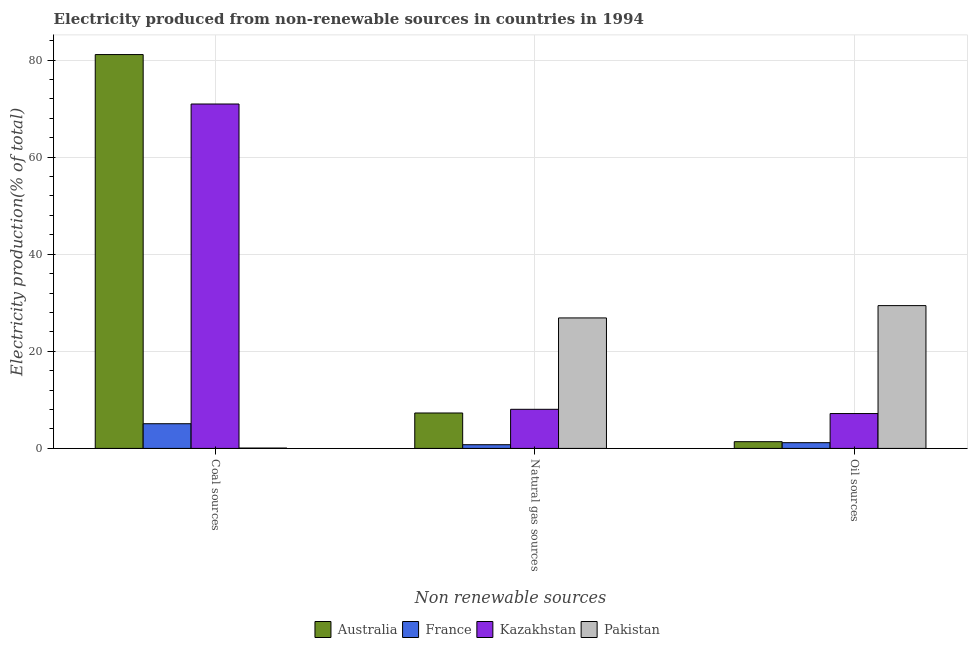How many different coloured bars are there?
Offer a very short reply. 4. How many groups of bars are there?
Your answer should be compact. 3. Are the number of bars on each tick of the X-axis equal?
Provide a short and direct response. Yes. What is the label of the 2nd group of bars from the left?
Your response must be concise. Natural gas sources. What is the percentage of electricity produced by natural gas in Australia?
Make the answer very short. 7.3. Across all countries, what is the maximum percentage of electricity produced by oil sources?
Ensure brevity in your answer.  29.41. Across all countries, what is the minimum percentage of electricity produced by natural gas?
Make the answer very short. 0.76. In which country was the percentage of electricity produced by oil sources maximum?
Provide a short and direct response. Pakistan. What is the total percentage of electricity produced by coal in the graph?
Offer a very short reply. 157.22. What is the difference between the percentage of electricity produced by natural gas in France and that in Australia?
Provide a short and direct response. -6.53. What is the difference between the percentage of electricity produced by natural gas in France and the percentage of electricity produced by coal in Pakistan?
Ensure brevity in your answer.  0.69. What is the average percentage of electricity produced by coal per country?
Provide a short and direct response. 39.3. What is the difference between the percentage of electricity produced by natural gas and percentage of electricity produced by coal in Kazakhstan?
Offer a terse response. -62.88. In how many countries, is the percentage of electricity produced by oil sources greater than 36 %?
Your answer should be compact. 0. What is the ratio of the percentage of electricity produced by coal in France to that in Australia?
Your answer should be compact. 0.06. Is the percentage of electricity produced by coal in France less than that in Kazakhstan?
Offer a very short reply. Yes. What is the difference between the highest and the second highest percentage of electricity produced by coal?
Offer a terse response. 10.18. What is the difference between the highest and the lowest percentage of electricity produced by oil sources?
Provide a succinct answer. 28.23. Is the sum of the percentage of electricity produced by oil sources in Kazakhstan and Pakistan greater than the maximum percentage of electricity produced by natural gas across all countries?
Provide a short and direct response. Yes. What does the 4th bar from the left in Natural gas sources represents?
Offer a very short reply. Pakistan. Is it the case that in every country, the sum of the percentage of electricity produced by coal and percentage of electricity produced by natural gas is greater than the percentage of electricity produced by oil sources?
Your answer should be compact. No. Are all the bars in the graph horizontal?
Provide a succinct answer. No. How many countries are there in the graph?
Offer a terse response. 4. Are the values on the major ticks of Y-axis written in scientific E-notation?
Provide a short and direct response. No. Does the graph contain any zero values?
Make the answer very short. No. Does the graph contain grids?
Offer a terse response. Yes. How many legend labels are there?
Offer a very short reply. 4. What is the title of the graph?
Offer a terse response. Electricity produced from non-renewable sources in countries in 1994. Does "Somalia" appear as one of the legend labels in the graph?
Give a very brief answer. No. What is the label or title of the X-axis?
Your answer should be very brief. Non renewable sources. What is the label or title of the Y-axis?
Make the answer very short. Electricity production(% of total). What is the Electricity production(% of total) in Australia in Coal sources?
Offer a terse response. 81.12. What is the Electricity production(% of total) in France in Coal sources?
Ensure brevity in your answer.  5.09. What is the Electricity production(% of total) in Kazakhstan in Coal sources?
Provide a short and direct response. 70.94. What is the Electricity production(% of total) of Pakistan in Coal sources?
Your answer should be very brief. 0.07. What is the Electricity production(% of total) of Australia in Natural gas sources?
Offer a terse response. 7.3. What is the Electricity production(% of total) of France in Natural gas sources?
Your answer should be very brief. 0.76. What is the Electricity production(% of total) in Kazakhstan in Natural gas sources?
Your answer should be compact. 8.06. What is the Electricity production(% of total) of Pakistan in Natural gas sources?
Make the answer very short. 26.88. What is the Electricity production(% of total) in Australia in Oil sources?
Make the answer very short. 1.39. What is the Electricity production(% of total) in France in Oil sources?
Make the answer very short. 1.18. What is the Electricity production(% of total) of Kazakhstan in Oil sources?
Ensure brevity in your answer.  7.18. What is the Electricity production(% of total) of Pakistan in Oil sources?
Provide a succinct answer. 29.41. Across all Non renewable sources, what is the maximum Electricity production(% of total) of Australia?
Ensure brevity in your answer.  81.12. Across all Non renewable sources, what is the maximum Electricity production(% of total) in France?
Your answer should be compact. 5.09. Across all Non renewable sources, what is the maximum Electricity production(% of total) in Kazakhstan?
Keep it short and to the point. 70.94. Across all Non renewable sources, what is the maximum Electricity production(% of total) in Pakistan?
Offer a very short reply. 29.41. Across all Non renewable sources, what is the minimum Electricity production(% of total) of Australia?
Provide a succinct answer. 1.39. Across all Non renewable sources, what is the minimum Electricity production(% of total) in France?
Your answer should be compact. 0.76. Across all Non renewable sources, what is the minimum Electricity production(% of total) of Kazakhstan?
Provide a succinct answer. 7.18. Across all Non renewable sources, what is the minimum Electricity production(% of total) of Pakistan?
Your answer should be very brief. 0.07. What is the total Electricity production(% of total) of Australia in the graph?
Your answer should be very brief. 89.81. What is the total Electricity production(% of total) of France in the graph?
Provide a succinct answer. 7.03. What is the total Electricity production(% of total) of Kazakhstan in the graph?
Offer a very short reply. 86.18. What is the total Electricity production(% of total) in Pakistan in the graph?
Ensure brevity in your answer.  56.36. What is the difference between the Electricity production(% of total) of Australia in Coal sources and that in Natural gas sources?
Offer a terse response. 73.82. What is the difference between the Electricity production(% of total) in France in Coal sources and that in Natural gas sources?
Make the answer very short. 4.32. What is the difference between the Electricity production(% of total) of Kazakhstan in Coal sources and that in Natural gas sources?
Provide a short and direct response. 62.88. What is the difference between the Electricity production(% of total) in Pakistan in Coal sources and that in Natural gas sources?
Make the answer very short. -26.8. What is the difference between the Electricity production(% of total) in Australia in Coal sources and that in Oil sources?
Your answer should be very brief. 79.73. What is the difference between the Electricity production(% of total) in France in Coal sources and that in Oil sources?
Give a very brief answer. 3.9. What is the difference between the Electricity production(% of total) of Kazakhstan in Coal sources and that in Oil sources?
Your answer should be compact. 63.76. What is the difference between the Electricity production(% of total) in Pakistan in Coal sources and that in Oil sources?
Give a very brief answer. -29.34. What is the difference between the Electricity production(% of total) of Australia in Natural gas sources and that in Oil sources?
Make the answer very short. 5.91. What is the difference between the Electricity production(% of total) in France in Natural gas sources and that in Oil sources?
Your response must be concise. -0.42. What is the difference between the Electricity production(% of total) of Kazakhstan in Natural gas sources and that in Oil sources?
Your answer should be compact. 0.88. What is the difference between the Electricity production(% of total) in Pakistan in Natural gas sources and that in Oil sources?
Ensure brevity in your answer.  -2.54. What is the difference between the Electricity production(% of total) in Australia in Coal sources and the Electricity production(% of total) in France in Natural gas sources?
Offer a terse response. 80.36. What is the difference between the Electricity production(% of total) of Australia in Coal sources and the Electricity production(% of total) of Kazakhstan in Natural gas sources?
Make the answer very short. 73.06. What is the difference between the Electricity production(% of total) of Australia in Coal sources and the Electricity production(% of total) of Pakistan in Natural gas sources?
Your response must be concise. 54.24. What is the difference between the Electricity production(% of total) in France in Coal sources and the Electricity production(% of total) in Kazakhstan in Natural gas sources?
Offer a very short reply. -2.97. What is the difference between the Electricity production(% of total) of France in Coal sources and the Electricity production(% of total) of Pakistan in Natural gas sources?
Offer a very short reply. -21.79. What is the difference between the Electricity production(% of total) in Kazakhstan in Coal sources and the Electricity production(% of total) in Pakistan in Natural gas sources?
Give a very brief answer. 44.06. What is the difference between the Electricity production(% of total) in Australia in Coal sources and the Electricity production(% of total) in France in Oil sources?
Your answer should be very brief. 79.94. What is the difference between the Electricity production(% of total) of Australia in Coal sources and the Electricity production(% of total) of Kazakhstan in Oil sources?
Keep it short and to the point. 73.94. What is the difference between the Electricity production(% of total) of Australia in Coal sources and the Electricity production(% of total) of Pakistan in Oil sources?
Ensure brevity in your answer.  51.71. What is the difference between the Electricity production(% of total) of France in Coal sources and the Electricity production(% of total) of Kazakhstan in Oil sources?
Offer a very short reply. -2.09. What is the difference between the Electricity production(% of total) of France in Coal sources and the Electricity production(% of total) of Pakistan in Oil sources?
Provide a short and direct response. -24.33. What is the difference between the Electricity production(% of total) of Kazakhstan in Coal sources and the Electricity production(% of total) of Pakistan in Oil sources?
Provide a succinct answer. 41.52. What is the difference between the Electricity production(% of total) in Australia in Natural gas sources and the Electricity production(% of total) in France in Oil sources?
Give a very brief answer. 6.11. What is the difference between the Electricity production(% of total) in Australia in Natural gas sources and the Electricity production(% of total) in Kazakhstan in Oil sources?
Your answer should be compact. 0.12. What is the difference between the Electricity production(% of total) in Australia in Natural gas sources and the Electricity production(% of total) in Pakistan in Oil sources?
Make the answer very short. -22.12. What is the difference between the Electricity production(% of total) of France in Natural gas sources and the Electricity production(% of total) of Kazakhstan in Oil sources?
Ensure brevity in your answer.  -6.42. What is the difference between the Electricity production(% of total) in France in Natural gas sources and the Electricity production(% of total) in Pakistan in Oil sources?
Give a very brief answer. -28.65. What is the difference between the Electricity production(% of total) of Kazakhstan in Natural gas sources and the Electricity production(% of total) of Pakistan in Oil sources?
Provide a succinct answer. -21.36. What is the average Electricity production(% of total) of Australia per Non renewable sources?
Your response must be concise. 29.94. What is the average Electricity production(% of total) in France per Non renewable sources?
Offer a terse response. 2.34. What is the average Electricity production(% of total) in Kazakhstan per Non renewable sources?
Your answer should be very brief. 28.73. What is the average Electricity production(% of total) in Pakistan per Non renewable sources?
Offer a terse response. 18.79. What is the difference between the Electricity production(% of total) in Australia and Electricity production(% of total) in France in Coal sources?
Your answer should be very brief. 76.03. What is the difference between the Electricity production(% of total) of Australia and Electricity production(% of total) of Kazakhstan in Coal sources?
Keep it short and to the point. 10.18. What is the difference between the Electricity production(% of total) of Australia and Electricity production(% of total) of Pakistan in Coal sources?
Your answer should be compact. 81.05. What is the difference between the Electricity production(% of total) of France and Electricity production(% of total) of Kazakhstan in Coal sources?
Give a very brief answer. -65.85. What is the difference between the Electricity production(% of total) in France and Electricity production(% of total) in Pakistan in Coal sources?
Offer a very short reply. 5.01. What is the difference between the Electricity production(% of total) in Kazakhstan and Electricity production(% of total) in Pakistan in Coal sources?
Offer a very short reply. 70.86. What is the difference between the Electricity production(% of total) of Australia and Electricity production(% of total) of France in Natural gas sources?
Your answer should be very brief. 6.53. What is the difference between the Electricity production(% of total) in Australia and Electricity production(% of total) in Kazakhstan in Natural gas sources?
Give a very brief answer. -0.76. What is the difference between the Electricity production(% of total) in Australia and Electricity production(% of total) in Pakistan in Natural gas sources?
Give a very brief answer. -19.58. What is the difference between the Electricity production(% of total) of France and Electricity production(% of total) of Kazakhstan in Natural gas sources?
Ensure brevity in your answer.  -7.29. What is the difference between the Electricity production(% of total) of France and Electricity production(% of total) of Pakistan in Natural gas sources?
Offer a terse response. -26.11. What is the difference between the Electricity production(% of total) in Kazakhstan and Electricity production(% of total) in Pakistan in Natural gas sources?
Offer a very short reply. -18.82. What is the difference between the Electricity production(% of total) in Australia and Electricity production(% of total) in France in Oil sources?
Provide a short and direct response. 0.2. What is the difference between the Electricity production(% of total) in Australia and Electricity production(% of total) in Kazakhstan in Oil sources?
Provide a succinct answer. -5.79. What is the difference between the Electricity production(% of total) in Australia and Electricity production(% of total) in Pakistan in Oil sources?
Your answer should be very brief. -28.02. What is the difference between the Electricity production(% of total) of France and Electricity production(% of total) of Kazakhstan in Oil sources?
Provide a short and direct response. -6. What is the difference between the Electricity production(% of total) in France and Electricity production(% of total) in Pakistan in Oil sources?
Your answer should be very brief. -28.23. What is the difference between the Electricity production(% of total) of Kazakhstan and Electricity production(% of total) of Pakistan in Oil sources?
Give a very brief answer. -22.23. What is the ratio of the Electricity production(% of total) in Australia in Coal sources to that in Natural gas sources?
Your response must be concise. 11.12. What is the ratio of the Electricity production(% of total) in France in Coal sources to that in Natural gas sources?
Ensure brevity in your answer.  6.66. What is the ratio of the Electricity production(% of total) in Kazakhstan in Coal sources to that in Natural gas sources?
Keep it short and to the point. 8.8. What is the ratio of the Electricity production(% of total) of Pakistan in Coal sources to that in Natural gas sources?
Make the answer very short. 0. What is the ratio of the Electricity production(% of total) in Australia in Coal sources to that in Oil sources?
Provide a short and direct response. 58.45. What is the ratio of the Electricity production(% of total) in France in Coal sources to that in Oil sources?
Your answer should be very brief. 4.3. What is the ratio of the Electricity production(% of total) of Kazakhstan in Coal sources to that in Oil sources?
Make the answer very short. 9.88. What is the ratio of the Electricity production(% of total) of Pakistan in Coal sources to that in Oil sources?
Provide a short and direct response. 0. What is the ratio of the Electricity production(% of total) of Australia in Natural gas sources to that in Oil sources?
Provide a short and direct response. 5.26. What is the ratio of the Electricity production(% of total) in France in Natural gas sources to that in Oil sources?
Keep it short and to the point. 0.65. What is the ratio of the Electricity production(% of total) of Kazakhstan in Natural gas sources to that in Oil sources?
Provide a succinct answer. 1.12. What is the ratio of the Electricity production(% of total) in Pakistan in Natural gas sources to that in Oil sources?
Your answer should be very brief. 0.91. What is the difference between the highest and the second highest Electricity production(% of total) of Australia?
Make the answer very short. 73.82. What is the difference between the highest and the second highest Electricity production(% of total) of France?
Keep it short and to the point. 3.9. What is the difference between the highest and the second highest Electricity production(% of total) of Kazakhstan?
Ensure brevity in your answer.  62.88. What is the difference between the highest and the second highest Electricity production(% of total) in Pakistan?
Ensure brevity in your answer.  2.54. What is the difference between the highest and the lowest Electricity production(% of total) of Australia?
Your response must be concise. 79.73. What is the difference between the highest and the lowest Electricity production(% of total) in France?
Make the answer very short. 4.32. What is the difference between the highest and the lowest Electricity production(% of total) of Kazakhstan?
Give a very brief answer. 63.76. What is the difference between the highest and the lowest Electricity production(% of total) in Pakistan?
Provide a succinct answer. 29.34. 